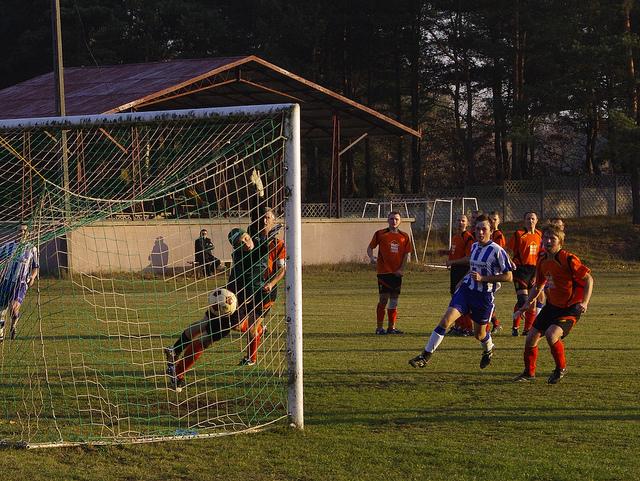What sport is this?
Give a very brief answer. Soccer. Would he be happy if this turns out to be nothing but net?
Be succinct. Yes. What object is blocking our view?
Keep it brief. Goal. Is someone making a goal?
Answer briefly. Yes. Is it a tennis court?
Answer briefly. No. What sport is shown?
Be succinct. Soccer. How many goals are there?
Write a very short answer. 2. Who kicked the ball?
Be succinct. Boy. What color is are the uniforms?
Write a very short answer. Orange. Is this an all girl sport?
Be succinct. No. 